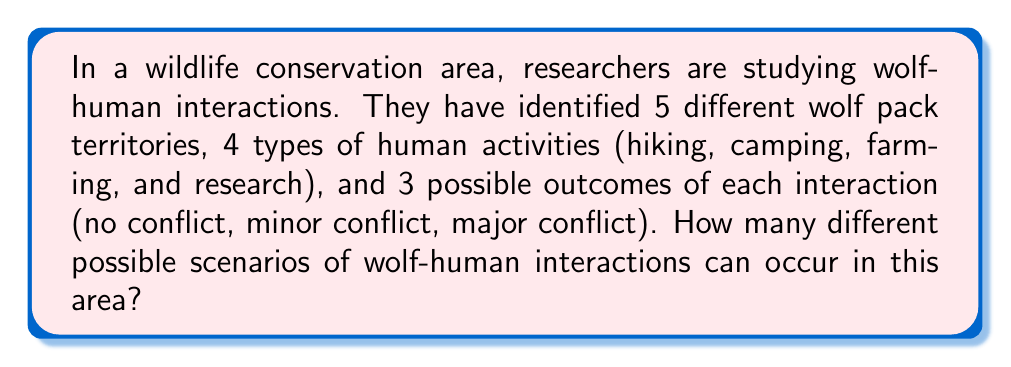Can you solve this math problem? Let's break this down step-by-step:

1) We need to use the multiplication principle of counting, as we're dealing with independent choices for each component of the scenario.

2) For each scenario, we need to choose:
   - A wolf pack territory (5 choices)
   - A type of human activity (4 choices)
   - An outcome of the interaction (3 choices)

3) According to the multiplication principle, if we have $m$ ways of doing something, $n$ ways of doing another thing, and $p$ ways of doing a third thing, then there are $m \times n \times p$ ways to do all three things.

4) In this case, we have:
   $$5 \text{ (wolf territories)} \times 4 \text{ (human activities)} \times 3 \text{ (outcomes)}$$

5) Let's calculate:
   $$5 \times 4 \times 3 = 60$$

Therefore, there are 60 different possible scenarios of wolf-human interactions in this conservation area.
Answer: 60 scenarios 